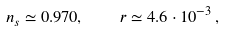<formula> <loc_0><loc_0><loc_500><loc_500>n _ { s } \simeq 0 . 9 7 0 , \quad r \simeq 4 . 6 \cdot 1 0 ^ { - 3 } \, ,</formula> 